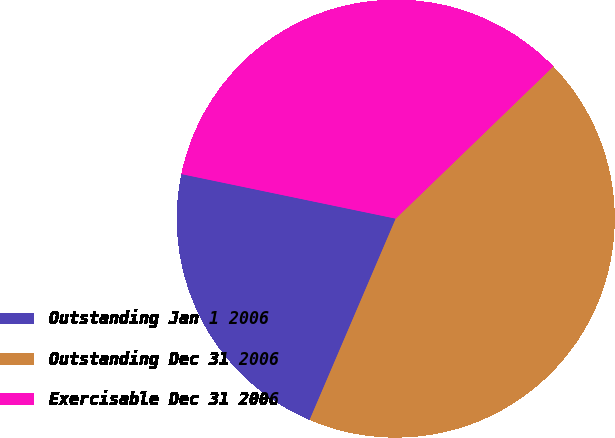Convert chart. <chart><loc_0><loc_0><loc_500><loc_500><pie_chart><fcel>Outstanding Jan 1 2006<fcel>Outstanding Dec 31 2006<fcel>Exercisable Dec 31 2006<nl><fcel>21.83%<fcel>43.66%<fcel>34.51%<nl></chart> 